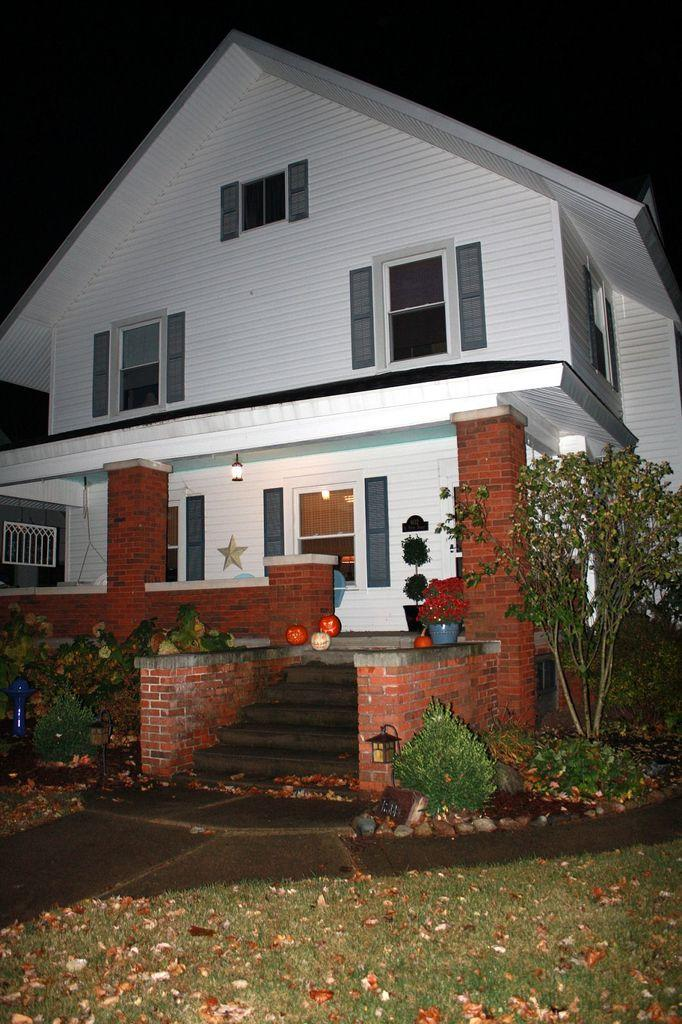What type of structure is visible in the image? There is a house in the image. What is located near the house? There is a sidewalk in the image. How can someone enter the house? There are stairs to enter the house. What type of vegetation is near the house? There is a tree on the side of the house. What type of heart is visible on the tree in the image? There is no heart visible on the tree in the image. How does the country move around in the image? The country does not move around in the image; it is a stationary location. 